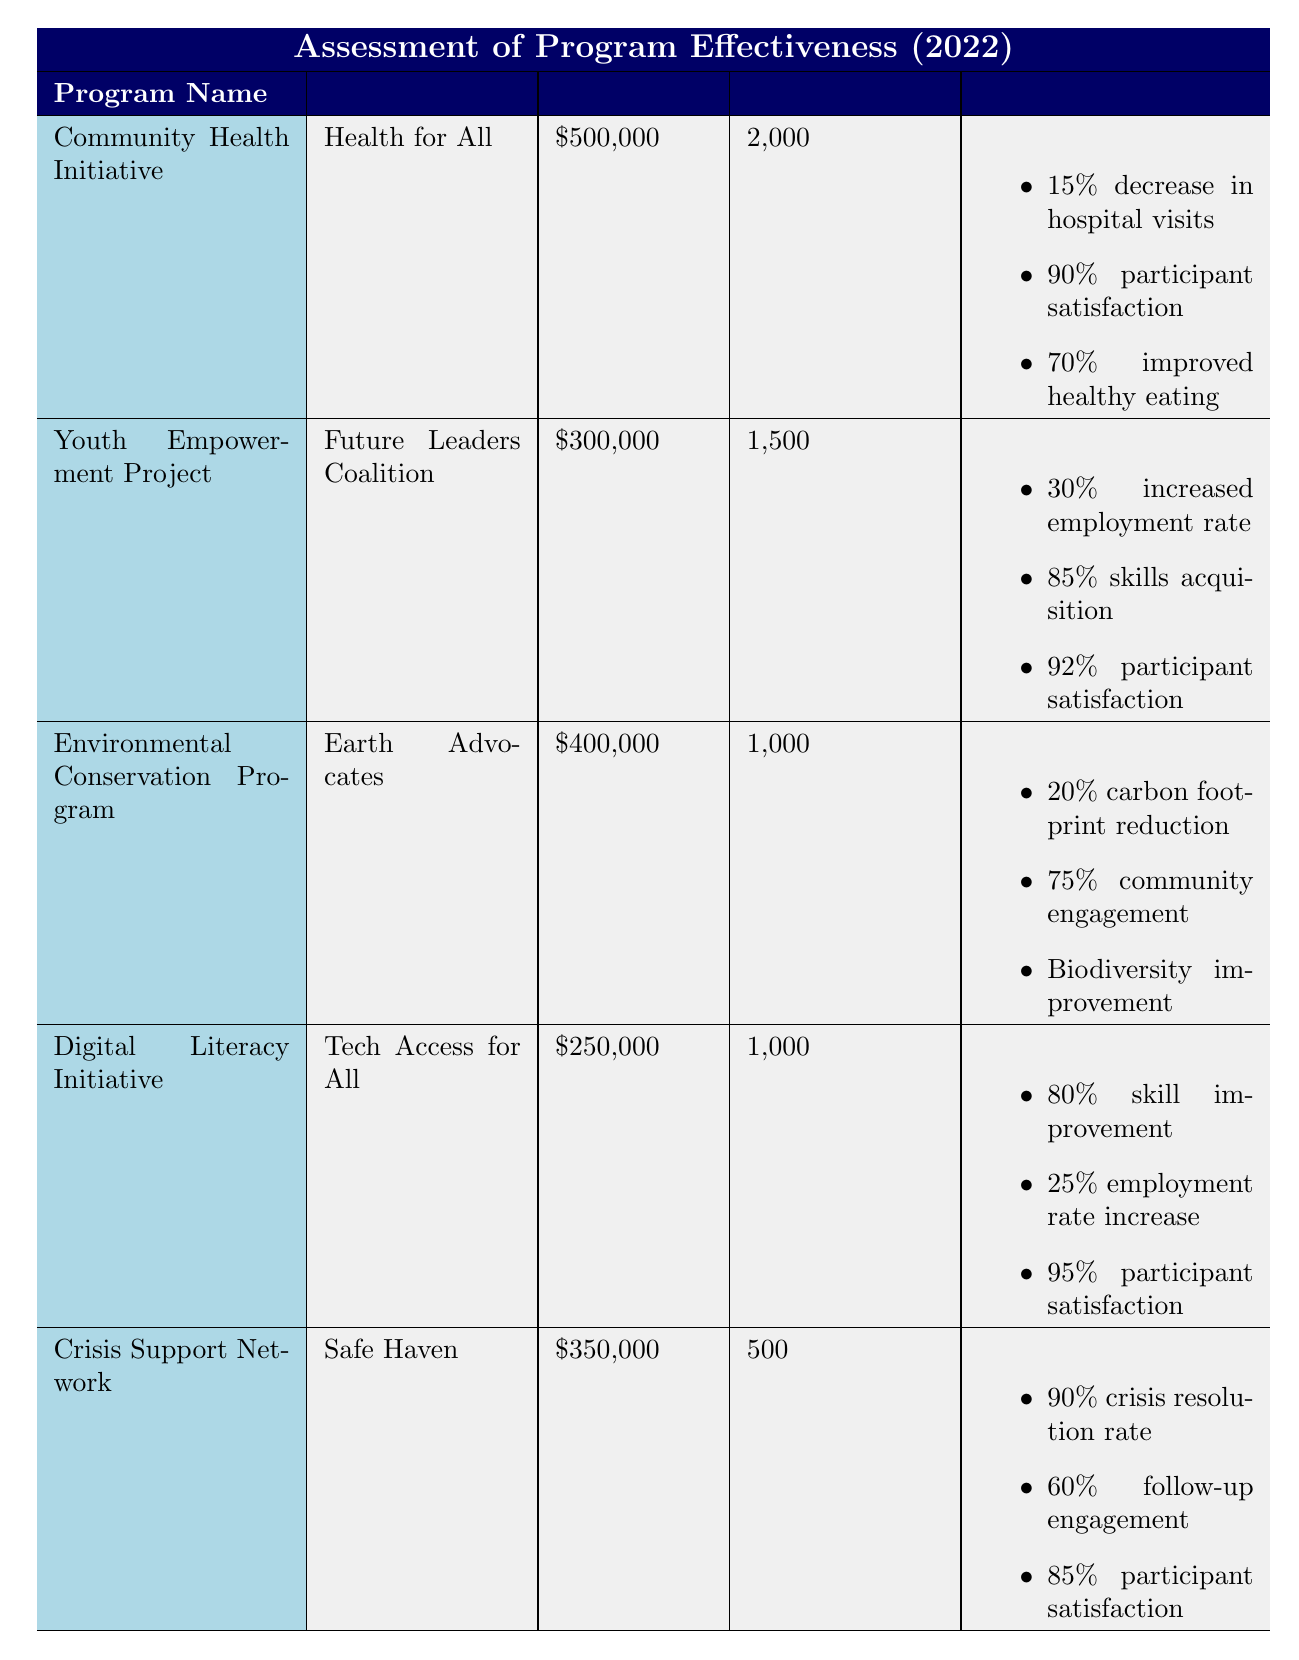What is the funding amount for the Digital Literacy Initiative? The table lists the funding amount for the Digital Literacy Initiative as $250,000.
Answer: $250,000 Which program has the highest participant satisfaction rate? The participant satisfaction rates are: Community Health Initiative (90%), Youth Empowerment Project (92%), Environmental Conservation Program (88%), Digital Literacy Initiative (95%), and Crisis Support Network (85%). The Digital Literacy Initiative has the highest satisfaction rate at 95%.
Answer: Digital Literacy Initiative What's the total funding amount for all programs combined? The funding amounts are: Community Health Initiative ($500,000), Youth Empowerment Project ($300,000), Environmental Conservation Program ($400,000), Digital Literacy Initiative ($250,000), and Crisis Support Network ($350,000). Adding them together gives a total of $500,000 + $300,000 + $400,000 + $250,000 + $350,000 = $1,800,000.
Answer: $1,800,000 Did the Environmental Conservation Program lead to an improvement in biodiversity? The outcomes for Environmental Conservation Program state that biodiversity improvement occurred, which indicates a positive outcome regarding biodiversity.
Answer: Yes What percentage of participants in the Crisis Support Network engaged in follow-up programs? The follow-up engagement rate for the Crisis Support Network is recorded as 60%.
Answer: 60% How does the number of participants in the Youth Empowerment Project compare to the Community Health Initiative? The Youth Empowerment Project had 1,500 participants, while the Community Health Initiative had 2,000 participants. The Community Health Initiative had 500 more participants than the Youth Empowerment Project.
Answer: Community Health Initiative had 500 more participants What is the average percentage of participant satisfaction across all programs? The participant satisfaction rates are: Community Health Initiative (90%), Youth Empowerment Project (92%), Environmental Conservation Program (88%), Digital Literacy Initiative (95%), and Crisis Support Network (85%). The average is calculated by adding these values (90 + 92 + 88 + 95 + 85 = 450) and then dividing by the number of programs (450 / 5 = 90).
Answer: 90 Which program has the lowest funding amount and what was its outcome regarding crisis resolution? The program with the lowest funding amount is the Digital Literacy Initiative with $250,000. The Crisis Support Network, which has the lowest participants at 500, achieved a crisis resolution rate of 90%.
Answer: Crisis Support Network; 90% resolution rate Which initiative had the most significant behavior change effect in healthy eating? The Community Health Initiative reported a healthy eating behavior change of 70%, which is the highest among the listed outcomes.
Answer: Community Health Initiative; 70% behavior change 